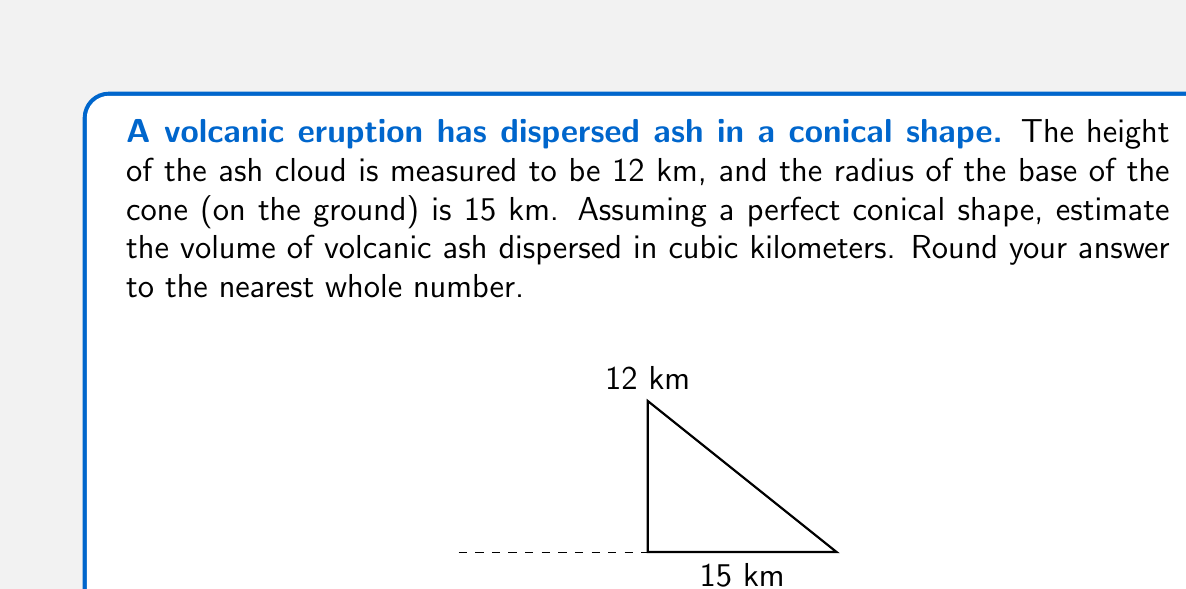Provide a solution to this math problem. To estimate the volume of volcanic ash dispersed, we can use the formula for the volume of a cone:

$$V = \frac{1}{3}\pi r^2 h$$

Where:
$V$ = volume of the cone
$r$ = radius of the base
$h$ = height of the cone

Given:
$r = 15$ km
$h = 12$ km

Let's substitute these values into the formula:

$$V = \frac{1}{3}\pi (15\text{ km})^2 (12\text{ km})$$

Simplifying:
$$V = \frac{1}{3}\pi (225\text{ km}^2) (12\text{ km})$$
$$V = 900\pi\text{ km}^3$$

Calculate the value:
$$V \approx 2,827.43\text{ km}^3$$

Rounding to the nearest whole number:
$$V \approx 2,827\text{ km}^3$$
Answer: $2,827\text{ km}^3$ 